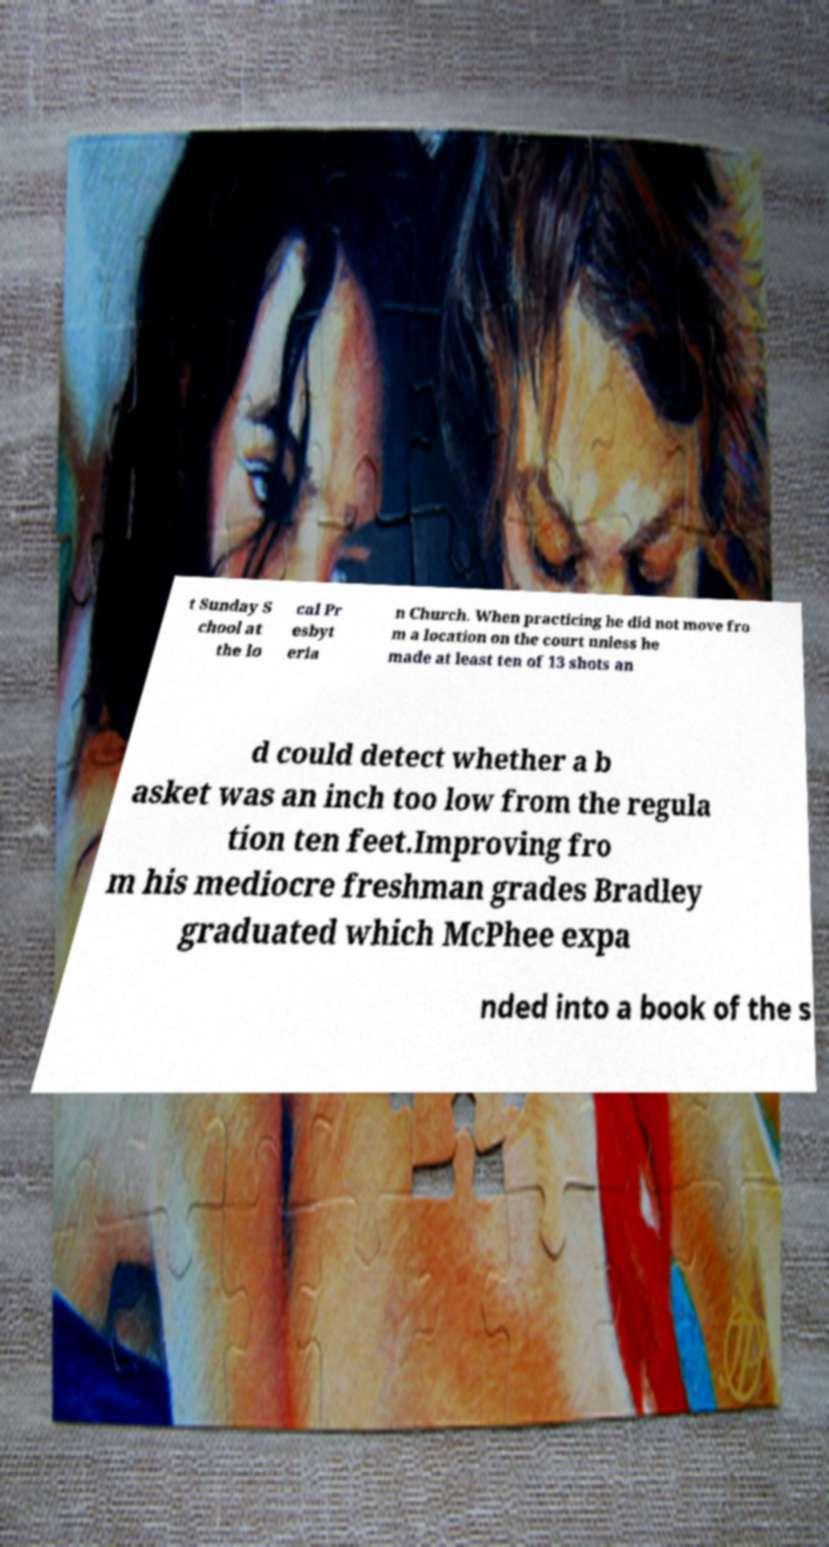For documentation purposes, I need the text within this image transcribed. Could you provide that? t Sunday S chool at the lo cal Pr esbyt eria n Church. When practicing he did not move fro m a location on the court unless he made at least ten of 13 shots an d could detect whether a b asket was an inch too low from the regula tion ten feet.Improving fro m his mediocre freshman grades Bradley graduated which McPhee expa nded into a book of the s 